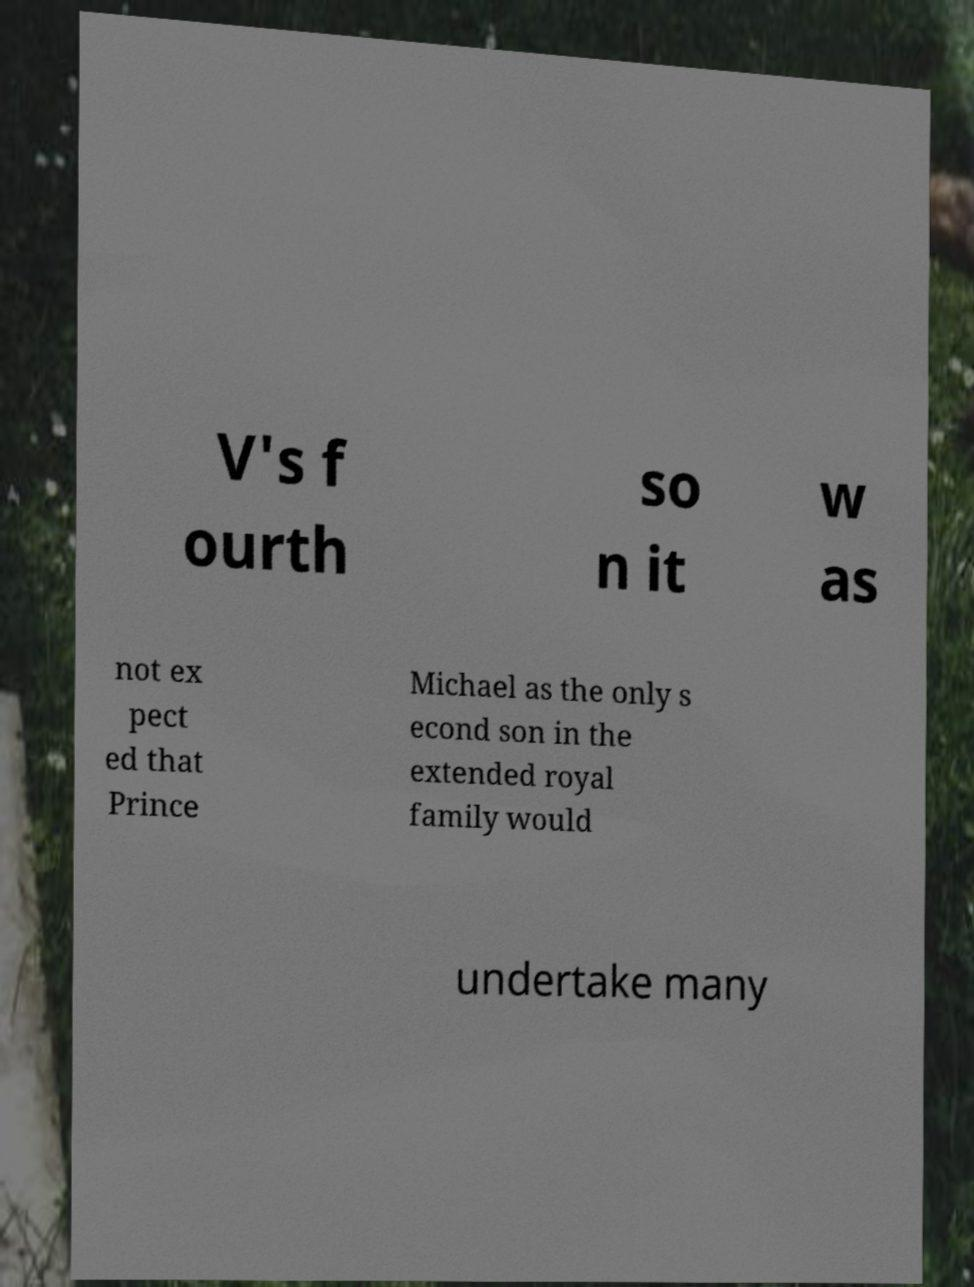I need the written content from this picture converted into text. Can you do that? V's f ourth so n it w as not ex pect ed that Prince Michael as the only s econd son in the extended royal family would undertake many 